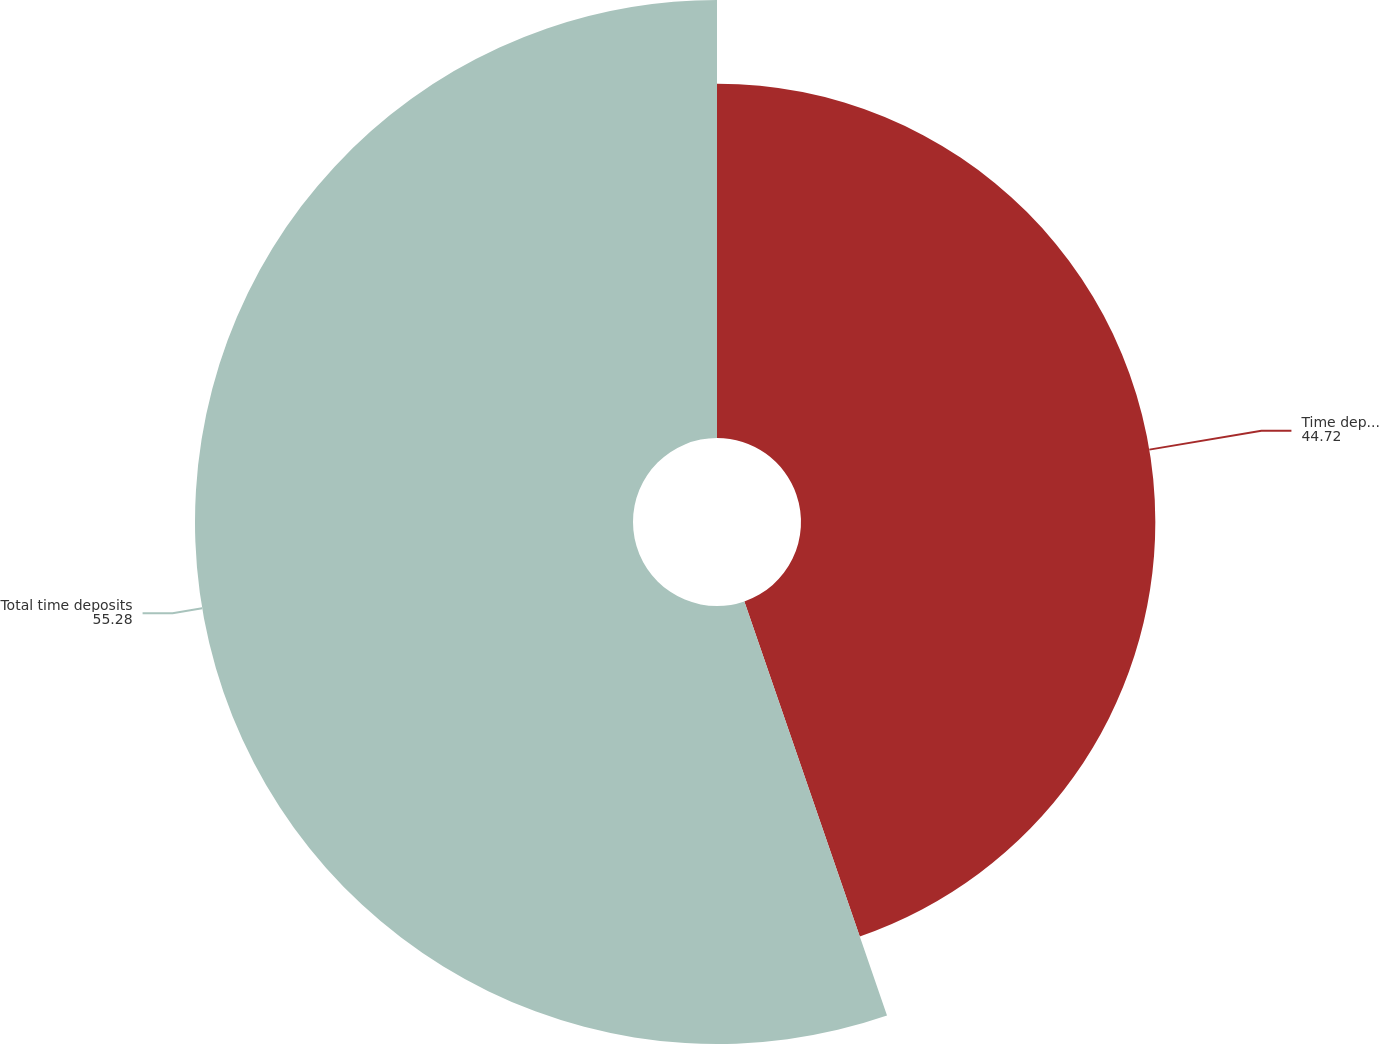<chart> <loc_0><loc_0><loc_500><loc_500><pie_chart><fcel>Time deposits 100000 and over<fcel>Total time deposits<nl><fcel>44.72%<fcel>55.28%<nl></chart> 